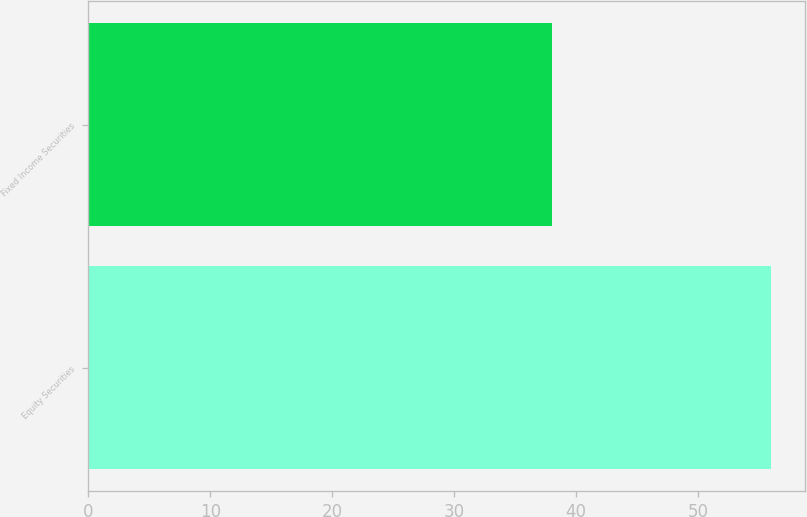Convert chart to OTSL. <chart><loc_0><loc_0><loc_500><loc_500><bar_chart><fcel>Equity Securities<fcel>Fixed Income Securities<nl><fcel>56<fcel>38<nl></chart> 